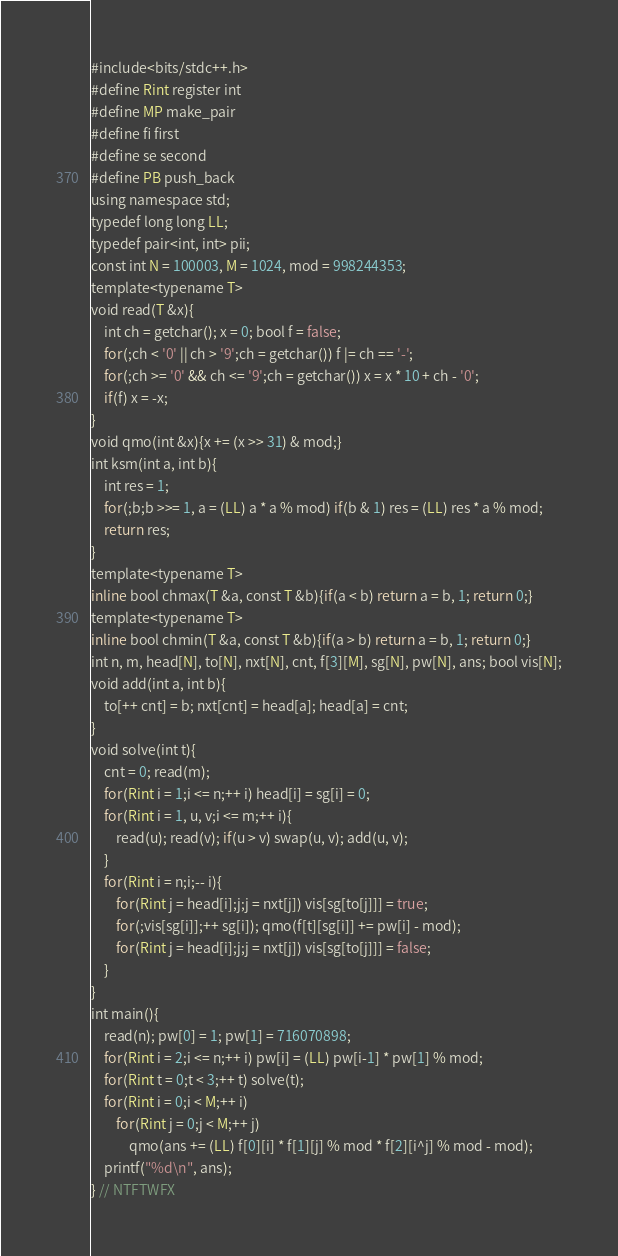<code> <loc_0><loc_0><loc_500><loc_500><_Scala_>#include<bits/stdc++.h>
#define Rint register int
#define MP make_pair
#define fi first
#define se second
#define PB push_back
using namespace std;
typedef long long LL;
typedef pair<int, int> pii;
const int N = 100003, M = 1024, mod = 998244353;
template<typename T>
void read(T &x){
	int ch = getchar(); x = 0; bool f = false;
	for(;ch < '0' || ch > '9';ch = getchar()) f |= ch == '-';
	for(;ch >= '0' && ch <= '9';ch = getchar()) x = x * 10 + ch - '0';
	if(f) x = -x;
}
void qmo(int &x){x += (x >> 31) & mod;}
int ksm(int a, int b){
	int res = 1;
	for(;b;b >>= 1, a = (LL) a * a % mod) if(b & 1) res = (LL) res * a % mod;
	return res;
}
template<typename T>
inline bool chmax(T &a, const T &b){if(a < b) return a = b, 1; return 0;}
template<typename T>
inline bool chmin(T &a, const T &b){if(a > b) return a = b, 1; return 0;}
int n, m, head[N], to[N], nxt[N], cnt, f[3][M], sg[N], pw[N], ans; bool vis[N];
void add(int a, int b){
	to[++ cnt] = b; nxt[cnt] = head[a]; head[a] = cnt;
}
void solve(int t){
	cnt = 0; read(m);
	for(Rint i = 1;i <= n;++ i) head[i] = sg[i] = 0;
	for(Rint i = 1, u, v;i <= m;++ i){
		read(u); read(v); if(u > v) swap(u, v); add(u, v);
	}
	for(Rint i = n;i;-- i){
		for(Rint j = head[i];j;j = nxt[j]) vis[sg[to[j]]] = true;
		for(;vis[sg[i]];++ sg[i]); qmo(f[t][sg[i]] += pw[i] - mod);
		for(Rint j = head[i];j;j = nxt[j]) vis[sg[to[j]]] = false;
	}
}
int main(){
	read(n); pw[0] = 1; pw[1] = 716070898;
	for(Rint i = 2;i <= n;++ i) pw[i] = (LL) pw[i-1] * pw[1] % mod;
	for(Rint t = 0;t < 3;++ t) solve(t);
	for(Rint i = 0;i < M;++ i)
		for(Rint j = 0;j < M;++ j)
			qmo(ans += (LL) f[0][i] * f[1][j] % mod * f[2][i^j] % mod - mod);
	printf("%d\n", ans);
} // NTFTWFX</code> 